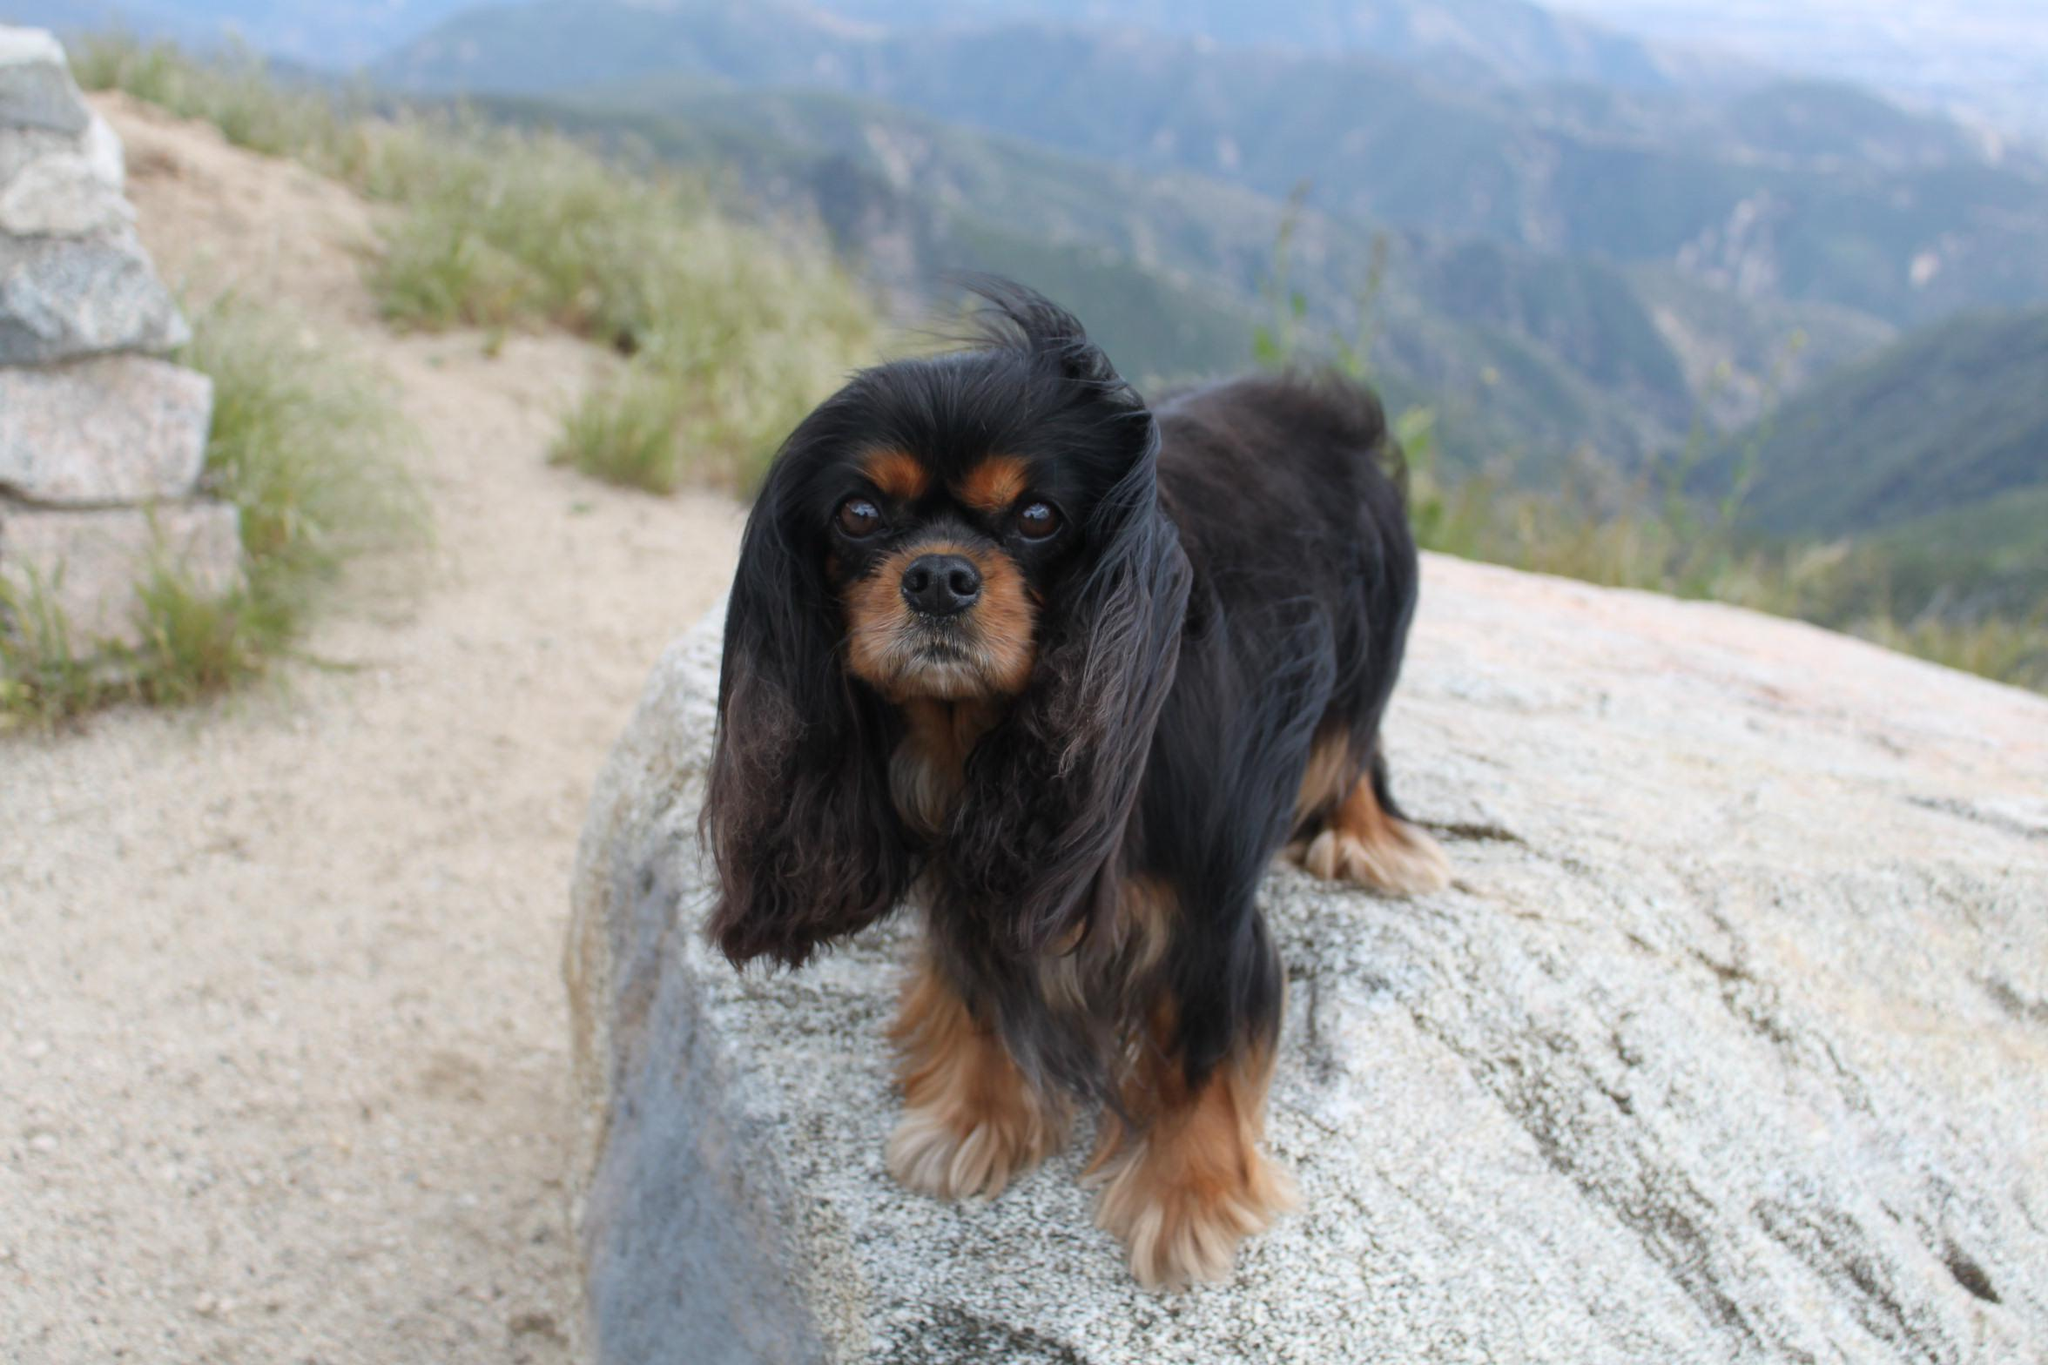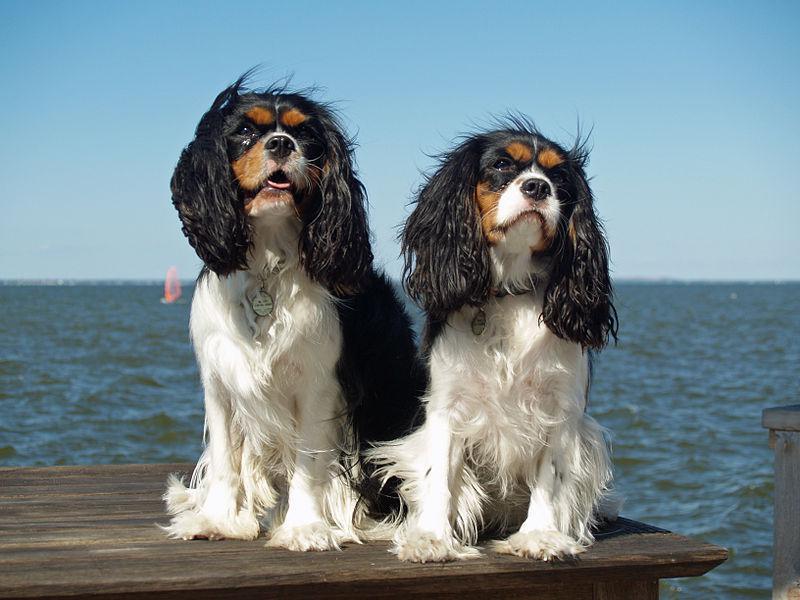The first image is the image on the left, the second image is the image on the right. Given the left and right images, does the statement "There are three cocker spaniels" hold true? Answer yes or no. Yes. The first image is the image on the left, the second image is the image on the right. For the images shown, is this caption "The dog on the left is sitting on a wood surface." true? Answer yes or no. No. The first image is the image on the left, the second image is the image on the right. Assess this claim about the two images: "One image shows a black and brown spaniel standing and looking up at the camera.". Correct or not? Answer yes or no. Yes. The first image is the image on the left, the second image is the image on the right. Assess this claim about the two images: "An image features two similarly colored dogs posed next to each other.". Correct or not? Answer yes or no. Yes. 